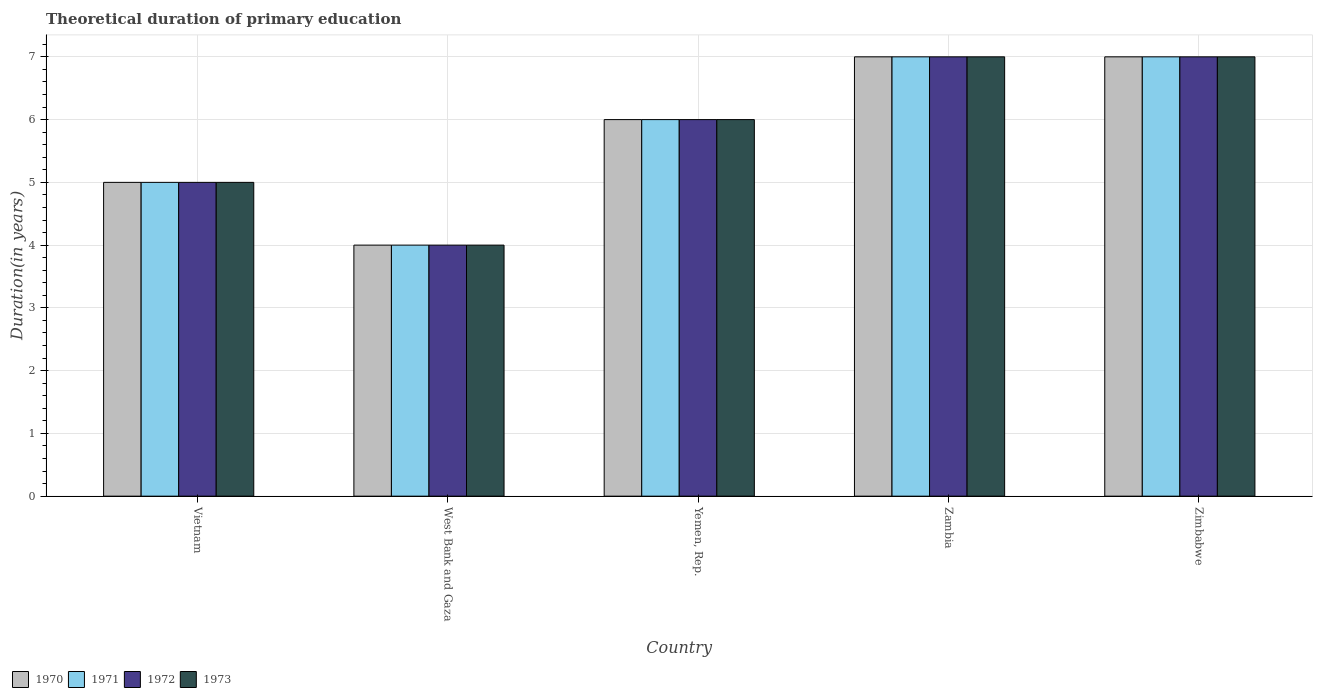How many different coloured bars are there?
Your response must be concise. 4. Are the number of bars per tick equal to the number of legend labels?
Provide a succinct answer. Yes. Are the number of bars on each tick of the X-axis equal?
Your answer should be compact. Yes. How many bars are there on the 2nd tick from the left?
Provide a short and direct response. 4. How many bars are there on the 1st tick from the right?
Keep it short and to the point. 4. What is the label of the 4th group of bars from the left?
Ensure brevity in your answer.  Zambia. In how many cases, is the number of bars for a given country not equal to the number of legend labels?
Your response must be concise. 0. Across all countries, what is the maximum total theoretical duration of primary education in 1972?
Offer a terse response. 7. In which country was the total theoretical duration of primary education in 1971 maximum?
Offer a terse response. Zambia. In which country was the total theoretical duration of primary education in 1972 minimum?
Make the answer very short. West Bank and Gaza. What is the average total theoretical duration of primary education in 1971 per country?
Your answer should be compact. 5.8. What is the difference between the total theoretical duration of primary education of/in 1973 and total theoretical duration of primary education of/in 1970 in Vietnam?
Ensure brevity in your answer.  0. In how many countries, is the total theoretical duration of primary education in 1972 greater than 0.2 years?
Provide a short and direct response. 5. What is the ratio of the total theoretical duration of primary education in 1973 in Zambia to that in Zimbabwe?
Your response must be concise. 1. Is the total theoretical duration of primary education in 1972 in West Bank and Gaza less than that in Zimbabwe?
Provide a short and direct response. Yes. What is the difference between the highest and the second highest total theoretical duration of primary education in 1972?
Offer a terse response. -1. What is the difference between the highest and the lowest total theoretical duration of primary education in 1972?
Your answer should be compact. 3. Is the sum of the total theoretical duration of primary education in 1970 in West Bank and Gaza and Yemen, Rep. greater than the maximum total theoretical duration of primary education in 1971 across all countries?
Make the answer very short. Yes. What does the 2nd bar from the right in Zambia represents?
Keep it short and to the point. 1972. Is it the case that in every country, the sum of the total theoretical duration of primary education in 1972 and total theoretical duration of primary education in 1971 is greater than the total theoretical duration of primary education in 1970?
Your answer should be compact. Yes. Are all the bars in the graph horizontal?
Offer a terse response. No. Does the graph contain grids?
Offer a terse response. Yes. What is the title of the graph?
Keep it short and to the point. Theoretical duration of primary education. Does "1963" appear as one of the legend labels in the graph?
Keep it short and to the point. No. What is the label or title of the X-axis?
Your answer should be very brief. Country. What is the label or title of the Y-axis?
Provide a succinct answer. Duration(in years). What is the Duration(in years) in 1970 in Vietnam?
Offer a very short reply. 5. What is the Duration(in years) of 1971 in Vietnam?
Give a very brief answer. 5. What is the Duration(in years) in 1972 in Vietnam?
Offer a terse response. 5. What is the Duration(in years) of 1973 in West Bank and Gaza?
Your answer should be very brief. 4. What is the Duration(in years) of 1970 in Yemen, Rep.?
Your answer should be compact. 6. What is the Duration(in years) in 1971 in Yemen, Rep.?
Give a very brief answer. 6. What is the Duration(in years) of 1973 in Yemen, Rep.?
Make the answer very short. 6. What is the Duration(in years) of 1973 in Zambia?
Your answer should be very brief. 7. What is the Duration(in years) of 1970 in Zimbabwe?
Give a very brief answer. 7. What is the Duration(in years) in 1972 in Zimbabwe?
Ensure brevity in your answer.  7. What is the Duration(in years) in 1973 in Zimbabwe?
Give a very brief answer. 7. Across all countries, what is the minimum Duration(in years) of 1970?
Your answer should be compact. 4. Across all countries, what is the minimum Duration(in years) in 1971?
Your answer should be compact. 4. Across all countries, what is the minimum Duration(in years) in 1972?
Make the answer very short. 4. Across all countries, what is the minimum Duration(in years) of 1973?
Ensure brevity in your answer.  4. What is the total Duration(in years) of 1970 in the graph?
Offer a terse response. 29. What is the total Duration(in years) of 1971 in the graph?
Provide a short and direct response. 29. What is the difference between the Duration(in years) in 1970 in Vietnam and that in West Bank and Gaza?
Keep it short and to the point. 1. What is the difference between the Duration(in years) of 1971 in Vietnam and that in West Bank and Gaza?
Make the answer very short. 1. What is the difference between the Duration(in years) in 1973 in Vietnam and that in West Bank and Gaza?
Keep it short and to the point. 1. What is the difference between the Duration(in years) in 1970 in Vietnam and that in Yemen, Rep.?
Provide a short and direct response. -1. What is the difference between the Duration(in years) of 1973 in Vietnam and that in Yemen, Rep.?
Your answer should be compact. -1. What is the difference between the Duration(in years) of 1971 in Vietnam and that in Zambia?
Provide a short and direct response. -2. What is the difference between the Duration(in years) of 1972 in Vietnam and that in Zambia?
Offer a very short reply. -2. What is the difference between the Duration(in years) in 1973 in Vietnam and that in Zambia?
Your answer should be very brief. -2. What is the difference between the Duration(in years) in 1973 in Vietnam and that in Zimbabwe?
Make the answer very short. -2. What is the difference between the Duration(in years) of 1971 in West Bank and Gaza and that in Yemen, Rep.?
Offer a terse response. -2. What is the difference between the Duration(in years) in 1973 in West Bank and Gaza and that in Yemen, Rep.?
Make the answer very short. -2. What is the difference between the Duration(in years) of 1970 in West Bank and Gaza and that in Zambia?
Give a very brief answer. -3. What is the difference between the Duration(in years) of 1972 in West Bank and Gaza and that in Zimbabwe?
Your answer should be very brief. -3. What is the difference between the Duration(in years) in 1970 in Yemen, Rep. and that in Zambia?
Ensure brevity in your answer.  -1. What is the difference between the Duration(in years) in 1971 in Yemen, Rep. and that in Zambia?
Provide a succinct answer. -1. What is the difference between the Duration(in years) of 1972 in Yemen, Rep. and that in Zambia?
Offer a very short reply. -1. What is the difference between the Duration(in years) of 1973 in Yemen, Rep. and that in Zambia?
Your answer should be very brief. -1. What is the difference between the Duration(in years) of 1971 in Yemen, Rep. and that in Zimbabwe?
Provide a succinct answer. -1. What is the difference between the Duration(in years) of 1972 in Yemen, Rep. and that in Zimbabwe?
Offer a very short reply. -1. What is the difference between the Duration(in years) of 1970 in Zambia and that in Zimbabwe?
Your answer should be compact. 0. What is the difference between the Duration(in years) of 1972 in Zambia and that in Zimbabwe?
Your answer should be compact. 0. What is the difference between the Duration(in years) of 1973 in Zambia and that in Zimbabwe?
Your answer should be compact. 0. What is the difference between the Duration(in years) in 1970 in Vietnam and the Duration(in years) in 1971 in West Bank and Gaza?
Make the answer very short. 1. What is the difference between the Duration(in years) in 1970 in Vietnam and the Duration(in years) in 1973 in West Bank and Gaza?
Offer a very short reply. 1. What is the difference between the Duration(in years) of 1971 in Vietnam and the Duration(in years) of 1973 in West Bank and Gaza?
Your answer should be compact. 1. What is the difference between the Duration(in years) of 1970 in Vietnam and the Duration(in years) of 1972 in Yemen, Rep.?
Ensure brevity in your answer.  -1. What is the difference between the Duration(in years) in 1971 in Vietnam and the Duration(in years) in 1972 in Yemen, Rep.?
Your answer should be compact. -1. What is the difference between the Duration(in years) of 1971 in Vietnam and the Duration(in years) of 1973 in Yemen, Rep.?
Your answer should be compact. -1. What is the difference between the Duration(in years) in 1970 in Vietnam and the Duration(in years) in 1971 in Zambia?
Provide a short and direct response. -2. What is the difference between the Duration(in years) in 1971 in Vietnam and the Duration(in years) in 1972 in Zambia?
Offer a very short reply. -2. What is the difference between the Duration(in years) of 1970 in Vietnam and the Duration(in years) of 1973 in Zimbabwe?
Offer a terse response. -2. What is the difference between the Duration(in years) of 1971 in Vietnam and the Duration(in years) of 1972 in Zimbabwe?
Your answer should be compact. -2. What is the difference between the Duration(in years) of 1970 in West Bank and Gaza and the Duration(in years) of 1971 in Yemen, Rep.?
Offer a terse response. -2. What is the difference between the Duration(in years) in 1970 in West Bank and Gaza and the Duration(in years) in 1973 in Yemen, Rep.?
Your response must be concise. -2. What is the difference between the Duration(in years) in 1971 in West Bank and Gaza and the Duration(in years) in 1973 in Yemen, Rep.?
Provide a short and direct response. -2. What is the difference between the Duration(in years) of 1970 in West Bank and Gaza and the Duration(in years) of 1973 in Zambia?
Make the answer very short. -3. What is the difference between the Duration(in years) of 1971 in West Bank and Gaza and the Duration(in years) of 1972 in Zambia?
Keep it short and to the point. -3. What is the difference between the Duration(in years) in 1971 in West Bank and Gaza and the Duration(in years) in 1973 in Zambia?
Your answer should be very brief. -3. What is the difference between the Duration(in years) of 1972 in West Bank and Gaza and the Duration(in years) of 1973 in Zambia?
Your response must be concise. -3. What is the difference between the Duration(in years) of 1970 in West Bank and Gaza and the Duration(in years) of 1971 in Zimbabwe?
Provide a short and direct response. -3. What is the difference between the Duration(in years) of 1970 in West Bank and Gaza and the Duration(in years) of 1972 in Zimbabwe?
Give a very brief answer. -3. What is the difference between the Duration(in years) in 1970 in West Bank and Gaza and the Duration(in years) in 1973 in Zimbabwe?
Give a very brief answer. -3. What is the difference between the Duration(in years) of 1971 in West Bank and Gaza and the Duration(in years) of 1973 in Zimbabwe?
Offer a terse response. -3. What is the difference between the Duration(in years) of 1972 in West Bank and Gaza and the Duration(in years) of 1973 in Zimbabwe?
Offer a very short reply. -3. What is the difference between the Duration(in years) of 1970 in Yemen, Rep. and the Duration(in years) of 1971 in Zambia?
Your response must be concise. -1. What is the difference between the Duration(in years) of 1970 in Yemen, Rep. and the Duration(in years) of 1973 in Zambia?
Your answer should be very brief. -1. What is the difference between the Duration(in years) in 1972 in Yemen, Rep. and the Duration(in years) in 1973 in Zambia?
Provide a succinct answer. -1. What is the difference between the Duration(in years) of 1970 in Yemen, Rep. and the Duration(in years) of 1972 in Zimbabwe?
Provide a short and direct response. -1. What is the difference between the Duration(in years) of 1970 in Yemen, Rep. and the Duration(in years) of 1973 in Zimbabwe?
Provide a succinct answer. -1. What is the difference between the Duration(in years) of 1972 in Yemen, Rep. and the Duration(in years) of 1973 in Zimbabwe?
Keep it short and to the point. -1. What is the difference between the Duration(in years) of 1970 in Zambia and the Duration(in years) of 1971 in Zimbabwe?
Provide a short and direct response. 0. What is the difference between the Duration(in years) in 1970 in Zambia and the Duration(in years) in 1972 in Zimbabwe?
Offer a terse response. 0. What is the difference between the Duration(in years) in 1970 in Zambia and the Duration(in years) in 1973 in Zimbabwe?
Your answer should be compact. 0. What is the average Duration(in years) in 1970 per country?
Give a very brief answer. 5.8. What is the average Duration(in years) in 1972 per country?
Make the answer very short. 5.8. What is the average Duration(in years) of 1973 per country?
Ensure brevity in your answer.  5.8. What is the difference between the Duration(in years) of 1970 and Duration(in years) of 1973 in Vietnam?
Ensure brevity in your answer.  0. What is the difference between the Duration(in years) of 1972 and Duration(in years) of 1973 in Vietnam?
Offer a very short reply. 0. What is the difference between the Duration(in years) in 1970 and Duration(in years) in 1972 in West Bank and Gaza?
Your answer should be very brief. 0. What is the difference between the Duration(in years) in 1970 and Duration(in years) in 1973 in West Bank and Gaza?
Keep it short and to the point. 0. What is the difference between the Duration(in years) of 1971 and Duration(in years) of 1972 in West Bank and Gaza?
Keep it short and to the point. 0. What is the difference between the Duration(in years) in 1972 and Duration(in years) in 1973 in West Bank and Gaza?
Make the answer very short. 0. What is the difference between the Duration(in years) in 1970 and Duration(in years) in 1972 in Yemen, Rep.?
Provide a succinct answer. 0. What is the difference between the Duration(in years) of 1970 and Duration(in years) of 1971 in Zambia?
Your answer should be compact. 0. What is the difference between the Duration(in years) of 1970 and Duration(in years) of 1973 in Zambia?
Ensure brevity in your answer.  0. What is the difference between the Duration(in years) in 1972 and Duration(in years) in 1973 in Zambia?
Your answer should be very brief. 0. What is the difference between the Duration(in years) in 1970 and Duration(in years) in 1971 in Zimbabwe?
Your response must be concise. 0. What is the difference between the Duration(in years) in 1970 and Duration(in years) in 1972 in Zimbabwe?
Keep it short and to the point. 0. What is the difference between the Duration(in years) of 1971 and Duration(in years) of 1972 in Zimbabwe?
Ensure brevity in your answer.  0. What is the difference between the Duration(in years) in 1971 and Duration(in years) in 1973 in Zimbabwe?
Make the answer very short. 0. What is the difference between the Duration(in years) in 1972 and Duration(in years) in 1973 in Zimbabwe?
Give a very brief answer. 0. What is the ratio of the Duration(in years) of 1970 in Vietnam to that in West Bank and Gaza?
Provide a succinct answer. 1.25. What is the ratio of the Duration(in years) of 1971 in Vietnam to that in West Bank and Gaza?
Give a very brief answer. 1.25. What is the ratio of the Duration(in years) of 1972 in Vietnam to that in West Bank and Gaza?
Ensure brevity in your answer.  1.25. What is the ratio of the Duration(in years) in 1970 in Vietnam to that in Yemen, Rep.?
Offer a very short reply. 0.83. What is the ratio of the Duration(in years) of 1971 in Vietnam to that in Yemen, Rep.?
Ensure brevity in your answer.  0.83. What is the ratio of the Duration(in years) of 1973 in Vietnam to that in Yemen, Rep.?
Provide a short and direct response. 0.83. What is the ratio of the Duration(in years) in 1970 in Vietnam to that in Zambia?
Your response must be concise. 0.71. What is the ratio of the Duration(in years) of 1971 in Vietnam to that in Zambia?
Give a very brief answer. 0.71. What is the ratio of the Duration(in years) of 1970 in West Bank and Gaza to that in Yemen, Rep.?
Your response must be concise. 0.67. What is the ratio of the Duration(in years) in 1971 in West Bank and Gaza to that in Yemen, Rep.?
Offer a very short reply. 0.67. What is the ratio of the Duration(in years) in 1972 in West Bank and Gaza to that in Yemen, Rep.?
Provide a succinct answer. 0.67. What is the ratio of the Duration(in years) in 1973 in West Bank and Gaza to that in Yemen, Rep.?
Your answer should be very brief. 0.67. What is the ratio of the Duration(in years) in 1970 in West Bank and Gaza to that in Zambia?
Offer a very short reply. 0.57. What is the ratio of the Duration(in years) in 1971 in West Bank and Gaza to that in Zambia?
Ensure brevity in your answer.  0.57. What is the ratio of the Duration(in years) of 1973 in West Bank and Gaza to that in Zambia?
Offer a terse response. 0.57. What is the ratio of the Duration(in years) in 1971 in West Bank and Gaza to that in Zimbabwe?
Give a very brief answer. 0.57. What is the ratio of the Duration(in years) in 1971 in Yemen, Rep. to that in Zambia?
Your response must be concise. 0.86. What is the ratio of the Duration(in years) of 1972 in Yemen, Rep. to that in Zambia?
Offer a terse response. 0.86. What is the ratio of the Duration(in years) in 1973 in Yemen, Rep. to that in Zambia?
Keep it short and to the point. 0.86. What is the ratio of the Duration(in years) in 1970 in Yemen, Rep. to that in Zimbabwe?
Offer a terse response. 0.86. What is the ratio of the Duration(in years) in 1971 in Zambia to that in Zimbabwe?
Provide a succinct answer. 1. What is the difference between the highest and the second highest Duration(in years) of 1970?
Make the answer very short. 0. What is the difference between the highest and the second highest Duration(in years) of 1971?
Provide a short and direct response. 0. What is the difference between the highest and the second highest Duration(in years) of 1972?
Your answer should be very brief. 0. What is the difference between the highest and the lowest Duration(in years) in 1970?
Your response must be concise. 3. What is the difference between the highest and the lowest Duration(in years) in 1971?
Give a very brief answer. 3. 